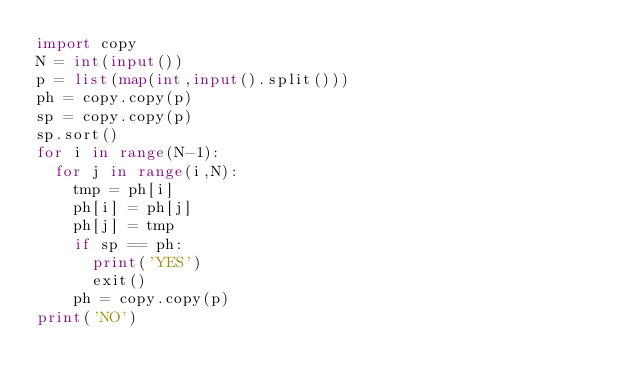Convert code to text. <code><loc_0><loc_0><loc_500><loc_500><_Python_>import copy
N = int(input())
p = list(map(int,input().split()))
ph = copy.copy(p)
sp = copy.copy(p)
sp.sort()
for i in range(N-1):
  for j in range(i,N):
    tmp = ph[i]
    ph[i] = ph[j]
    ph[j] = tmp
    if sp == ph:
      print('YES')
      exit()
    ph = copy.copy(p)
print('NO')
</code> 